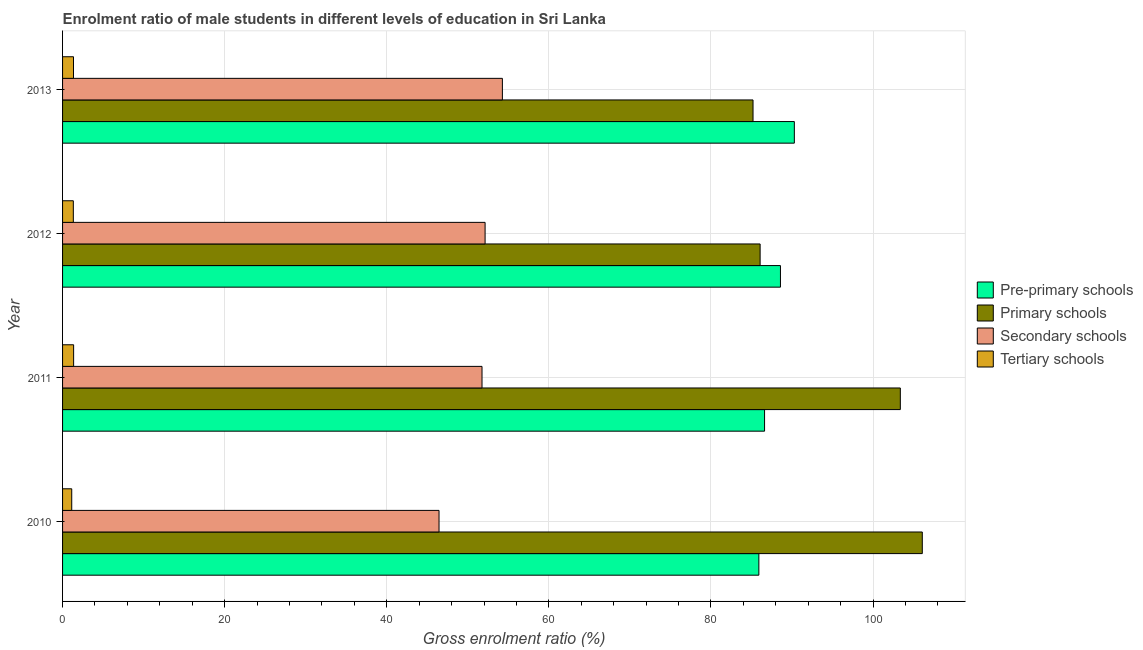How many different coloured bars are there?
Keep it short and to the point. 4. How many groups of bars are there?
Ensure brevity in your answer.  4. How many bars are there on the 4th tick from the bottom?
Keep it short and to the point. 4. In how many cases, is the number of bars for a given year not equal to the number of legend labels?
Offer a very short reply. 0. What is the gross enrolment ratio(female) in secondary schools in 2010?
Ensure brevity in your answer.  46.45. Across all years, what is the maximum gross enrolment ratio(female) in primary schools?
Give a very brief answer. 106.08. Across all years, what is the minimum gross enrolment ratio(female) in secondary schools?
Provide a short and direct response. 46.45. In which year was the gross enrolment ratio(female) in secondary schools minimum?
Provide a succinct answer. 2010. What is the total gross enrolment ratio(female) in tertiary schools in the graph?
Give a very brief answer. 5.17. What is the difference between the gross enrolment ratio(female) in tertiary schools in 2013 and the gross enrolment ratio(female) in pre-primary schools in 2011?
Provide a succinct answer. -85.27. What is the average gross enrolment ratio(female) in pre-primary schools per year?
Your response must be concise. 87.85. In the year 2010, what is the difference between the gross enrolment ratio(female) in secondary schools and gross enrolment ratio(female) in pre-primary schools?
Your answer should be very brief. -39.46. In how many years, is the gross enrolment ratio(female) in pre-primary schools greater than 20 %?
Your answer should be very brief. 4. What is the ratio of the gross enrolment ratio(female) in primary schools in 2012 to that in 2013?
Offer a terse response. 1.01. Is the difference between the gross enrolment ratio(female) in tertiary schools in 2010 and 2013 greater than the difference between the gross enrolment ratio(female) in secondary schools in 2010 and 2013?
Your response must be concise. Yes. What is the difference between the highest and the second highest gross enrolment ratio(female) in pre-primary schools?
Offer a very short reply. 1.71. What is the difference between the highest and the lowest gross enrolment ratio(female) in primary schools?
Your answer should be very brief. 20.89. What does the 3rd bar from the top in 2013 represents?
Provide a short and direct response. Primary schools. What does the 1st bar from the bottom in 2010 represents?
Offer a very short reply. Pre-primary schools. Are all the bars in the graph horizontal?
Keep it short and to the point. Yes. Does the graph contain any zero values?
Offer a terse response. No. Does the graph contain grids?
Provide a short and direct response. Yes. What is the title of the graph?
Your answer should be compact. Enrolment ratio of male students in different levels of education in Sri Lanka. What is the label or title of the X-axis?
Ensure brevity in your answer.  Gross enrolment ratio (%). What is the Gross enrolment ratio (%) in Pre-primary schools in 2010?
Your answer should be very brief. 85.91. What is the Gross enrolment ratio (%) in Primary schools in 2010?
Your answer should be compact. 106.08. What is the Gross enrolment ratio (%) of Secondary schools in 2010?
Keep it short and to the point. 46.45. What is the Gross enrolment ratio (%) of Tertiary schools in 2010?
Ensure brevity in your answer.  1.13. What is the Gross enrolment ratio (%) of Pre-primary schools in 2011?
Offer a very short reply. 86.62. What is the Gross enrolment ratio (%) of Primary schools in 2011?
Ensure brevity in your answer.  103.37. What is the Gross enrolment ratio (%) of Secondary schools in 2011?
Provide a succinct answer. 51.76. What is the Gross enrolment ratio (%) in Tertiary schools in 2011?
Make the answer very short. 1.36. What is the Gross enrolment ratio (%) in Pre-primary schools in 2012?
Offer a terse response. 88.58. What is the Gross enrolment ratio (%) of Primary schools in 2012?
Provide a succinct answer. 86.07. What is the Gross enrolment ratio (%) in Secondary schools in 2012?
Offer a terse response. 52.14. What is the Gross enrolment ratio (%) of Tertiary schools in 2012?
Provide a succinct answer. 1.33. What is the Gross enrolment ratio (%) of Pre-primary schools in 2013?
Provide a short and direct response. 90.29. What is the Gross enrolment ratio (%) in Primary schools in 2013?
Your answer should be compact. 85.19. What is the Gross enrolment ratio (%) of Secondary schools in 2013?
Offer a terse response. 54.27. What is the Gross enrolment ratio (%) of Tertiary schools in 2013?
Make the answer very short. 1.35. Across all years, what is the maximum Gross enrolment ratio (%) of Pre-primary schools?
Keep it short and to the point. 90.29. Across all years, what is the maximum Gross enrolment ratio (%) in Primary schools?
Offer a very short reply. 106.08. Across all years, what is the maximum Gross enrolment ratio (%) in Secondary schools?
Your response must be concise. 54.27. Across all years, what is the maximum Gross enrolment ratio (%) in Tertiary schools?
Make the answer very short. 1.36. Across all years, what is the minimum Gross enrolment ratio (%) in Pre-primary schools?
Ensure brevity in your answer.  85.91. Across all years, what is the minimum Gross enrolment ratio (%) in Primary schools?
Offer a terse response. 85.19. Across all years, what is the minimum Gross enrolment ratio (%) in Secondary schools?
Provide a succinct answer. 46.45. Across all years, what is the minimum Gross enrolment ratio (%) of Tertiary schools?
Give a very brief answer. 1.13. What is the total Gross enrolment ratio (%) in Pre-primary schools in the graph?
Keep it short and to the point. 351.4. What is the total Gross enrolment ratio (%) of Primary schools in the graph?
Your answer should be very brief. 380.72. What is the total Gross enrolment ratio (%) of Secondary schools in the graph?
Ensure brevity in your answer.  204.61. What is the total Gross enrolment ratio (%) in Tertiary schools in the graph?
Your response must be concise. 5.17. What is the difference between the Gross enrolment ratio (%) of Pre-primary schools in 2010 and that in 2011?
Keep it short and to the point. -0.7. What is the difference between the Gross enrolment ratio (%) of Primary schools in 2010 and that in 2011?
Ensure brevity in your answer.  2.71. What is the difference between the Gross enrolment ratio (%) in Secondary schools in 2010 and that in 2011?
Give a very brief answer. -5.3. What is the difference between the Gross enrolment ratio (%) in Tertiary schools in 2010 and that in 2011?
Offer a terse response. -0.23. What is the difference between the Gross enrolment ratio (%) of Pre-primary schools in 2010 and that in 2012?
Keep it short and to the point. -2.67. What is the difference between the Gross enrolment ratio (%) of Primary schools in 2010 and that in 2012?
Make the answer very short. 20.01. What is the difference between the Gross enrolment ratio (%) in Secondary schools in 2010 and that in 2012?
Make the answer very short. -5.68. What is the difference between the Gross enrolment ratio (%) of Tertiary schools in 2010 and that in 2012?
Your response must be concise. -0.2. What is the difference between the Gross enrolment ratio (%) in Pre-primary schools in 2010 and that in 2013?
Keep it short and to the point. -4.38. What is the difference between the Gross enrolment ratio (%) in Primary schools in 2010 and that in 2013?
Give a very brief answer. 20.89. What is the difference between the Gross enrolment ratio (%) in Secondary schools in 2010 and that in 2013?
Offer a terse response. -7.82. What is the difference between the Gross enrolment ratio (%) of Tertiary schools in 2010 and that in 2013?
Provide a succinct answer. -0.22. What is the difference between the Gross enrolment ratio (%) in Pre-primary schools in 2011 and that in 2012?
Provide a short and direct response. -1.96. What is the difference between the Gross enrolment ratio (%) in Primary schools in 2011 and that in 2012?
Ensure brevity in your answer.  17.3. What is the difference between the Gross enrolment ratio (%) of Secondary schools in 2011 and that in 2012?
Provide a short and direct response. -0.38. What is the difference between the Gross enrolment ratio (%) of Tertiary schools in 2011 and that in 2012?
Provide a succinct answer. 0.04. What is the difference between the Gross enrolment ratio (%) in Pre-primary schools in 2011 and that in 2013?
Offer a very short reply. -3.68. What is the difference between the Gross enrolment ratio (%) in Primary schools in 2011 and that in 2013?
Give a very brief answer. 18.18. What is the difference between the Gross enrolment ratio (%) in Secondary schools in 2011 and that in 2013?
Give a very brief answer. -2.51. What is the difference between the Gross enrolment ratio (%) of Tertiary schools in 2011 and that in 2013?
Ensure brevity in your answer.  0.02. What is the difference between the Gross enrolment ratio (%) in Pre-primary schools in 2012 and that in 2013?
Provide a succinct answer. -1.71. What is the difference between the Gross enrolment ratio (%) in Primary schools in 2012 and that in 2013?
Ensure brevity in your answer.  0.88. What is the difference between the Gross enrolment ratio (%) in Secondary schools in 2012 and that in 2013?
Keep it short and to the point. -2.13. What is the difference between the Gross enrolment ratio (%) in Tertiary schools in 2012 and that in 2013?
Your answer should be very brief. -0.02. What is the difference between the Gross enrolment ratio (%) in Pre-primary schools in 2010 and the Gross enrolment ratio (%) in Primary schools in 2011?
Your answer should be very brief. -17.46. What is the difference between the Gross enrolment ratio (%) of Pre-primary schools in 2010 and the Gross enrolment ratio (%) of Secondary schools in 2011?
Make the answer very short. 34.16. What is the difference between the Gross enrolment ratio (%) in Pre-primary schools in 2010 and the Gross enrolment ratio (%) in Tertiary schools in 2011?
Keep it short and to the point. 84.55. What is the difference between the Gross enrolment ratio (%) of Primary schools in 2010 and the Gross enrolment ratio (%) of Secondary schools in 2011?
Your answer should be compact. 54.33. What is the difference between the Gross enrolment ratio (%) of Primary schools in 2010 and the Gross enrolment ratio (%) of Tertiary schools in 2011?
Offer a terse response. 104.72. What is the difference between the Gross enrolment ratio (%) of Secondary schools in 2010 and the Gross enrolment ratio (%) of Tertiary schools in 2011?
Keep it short and to the point. 45.09. What is the difference between the Gross enrolment ratio (%) in Pre-primary schools in 2010 and the Gross enrolment ratio (%) in Primary schools in 2012?
Make the answer very short. -0.16. What is the difference between the Gross enrolment ratio (%) of Pre-primary schools in 2010 and the Gross enrolment ratio (%) of Secondary schools in 2012?
Your answer should be compact. 33.78. What is the difference between the Gross enrolment ratio (%) of Pre-primary schools in 2010 and the Gross enrolment ratio (%) of Tertiary schools in 2012?
Your response must be concise. 84.59. What is the difference between the Gross enrolment ratio (%) in Primary schools in 2010 and the Gross enrolment ratio (%) in Secondary schools in 2012?
Provide a short and direct response. 53.95. What is the difference between the Gross enrolment ratio (%) of Primary schools in 2010 and the Gross enrolment ratio (%) of Tertiary schools in 2012?
Offer a very short reply. 104.75. What is the difference between the Gross enrolment ratio (%) in Secondary schools in 2010 and the Gross enrolment ratio (%) in Tertiary schools in 2012?
Keep it short and to the point. 45.12. What is the difference between the Gross enrolment ratio (%) in Pre-primary schools in 2010 and the Gross enrolment ratio (%) in Primary schools in 2013?
Ensure brevity in your answer.  0.72. What is the difference between the Gross enrolment ratio (%) in Pre-primary schools in 2010 and the Gross enrolment ratio (%) in Secondary schools in 2013?
Provide a succinct answer. 31.64. What is the difference between the Gross enrolment ratio (%) in Pre-primary schools in 2010 and the Gross enrolment ratio (%) in Tertiary schools in 2013?
Your answer should be very brief. 84.57. What is the difference between the Gross enrolment ratio (%) of Primary schools in 2010 and the Gross enrolment ratio (%) of Secondary schools in 2013?
Your response must be concise. 51.81. What is the difference between the Gross enrolment ratio (%) of Primary schools in 2010 and the Gross enrolment ratio (%) of Tertiary schools in 2013?
Keep it short and to the point. 104.73. What is the difference between the Gross enrolment ratio (%) of Secondary schools in 2010 and the Gross enrolment ratio (%) of Tertiary schools in 2013?
Ensure brevity in your answer.  45.1. What is the difference between the Gross enrolment ratio (%) in Pre-primary schools in 2011 and the Gross enrolment ratio (%) in Primary schools in 2012?
Keep it short and to the point. 0.55. What is the difference between the Gross enrolment ratio (%) in Pre-primary schools in 2011 and the Gross enrolment ratio (%) in Secondary schools in 2012?
Provide a short and direct response. 34.48. What is the difference between the Gross enrolment ratio (%) of Pre-primary schools in 2011 and the Gross enrolment ratio (%) of Tertiary schools in 2012?
Keep it short and to the point. 85.29. What is the difference between the Gross enrolment ratio (%) in Primary schools in 2011 and the Gross enrolment ratio (%) in Secondary schools in 2012?
Your answer should be compact. 51.23. What is the difference between the Gross enrolment ratio (%) of Primary schools in 2011 and the Gross enrolment ratio (%) of Tertiary schools in 2012?
Keep it short and to the point. 102.04. What is the difference between the Gross enrolment ratio (%) in Secondary schools in 2011 and the Gross enrolment ratio (%) in Tertiary schools in 2012?
Offer a terse response. 50.43. What is the difference between the Gross enrolment ratio (%) in Pre-primary schools in 2011 and the Gross enrolment ratio (%) in Primary schools in 2013?
Provide a short and direct response. 1.42. What is the difference between the Gross enrolment ratio (%) in Pre-primary schools in 2011 and the Gross enrolment ratio (%) in Secondary schools in 2013?
Make the answer very short. 32.35. What is the difference between the Gross enrolment ratio (%) of Pre-primary schools in 2011 and the Gross enrolment ratio (%) of Tertiary schools in 2013?
Give a very brief answer. 85.27. What is the difference between the Gross enrolment ratio (%) in Primary schools in 2011 and the Gross enrolment ratio (%) in Secondary schools in 2013?
Keep it short and to the point. 49.1. What is the difference between the Gross enrolment ratio (%) in Primary schools in 2011 and the Gross enrolment ratio (%) in Tertiary schools in 2013?
Provide a short and direct response. 102.02. What is the difference between the Gross enrolment ratio (%) in Secondary schools in 2011 and the Gross enrolment ratio (%) in Tertiary schools in 2013?
Your answer should be compact. 50.41. What is the difference between the Gross enrolment ratio (%) in Pre-primary schools in 2012 and the Gross enrolment ratio (%) in Primary schools in 2013?
Provide a short and direct response. 3.38. What is the difference between the Gross enrolment ratio (%) in Pre-primary schools in 2012 and the Gross enrolment ratio (%) in Secondary schools in 2013?
Offer a very short reply. 34.31. What is the difference between the Gross enrolment ratio (%) in Pre-primary schools in 2012 and the Gross enrolment ratio (%) in Tertiary schools in 2013?
Keep it short and to the point. 87.23. What is the difference between the Gross enrolment ratio (%) of Primary schools in 2012 and the Gross enrolment ratio (%) of Secondary schools in 2013?
Offer a terse response. 31.8. What is the difference between the Gross enrolment ratio (%) in Primary schools in 2012 and the Gross enrolment ratio (%) in Tertiary schools in 2013?
Provide a succinct answer. 84.72. What is the difference between the Gross enrolment ratio (%) in Secondary schools in 2012 and the Gross enrolment ratio (%) in Tertiary schools in 2013?
Ensure brevity in your answer.  50.79. What is the average Gross enrolment ratio (%) in Pre-primary schools per year?
Keep it short and to the point. 87.85. What is the average Gross enrolment ratio (%) in Primary schools per year?
Your answer should be very brief. 95.18. What is the average Gross enrolment ratio (%) in Secondary schools per year?
Offer a very short reply. 51.15. What is the average Gross enrolment ratio (%) in Tertiary schools per year?
Provide a short and direct response. 1.29. In the year 2010, what is the difference between the Gross enrolment ratio (%) in Pre-primary schools and Gross enrolment ratio (%) in Primary schools?
Give a very brief answer. -20.17. In the year 2010, what is the difference between the Gross enrolment ratio (%) of Pre-primary schools and Gross enrolment ratio (%) of Secondary schools?
Provide a succinct answer. 39.46. In the year 2010, what is the difference between the Gross enrolment ratio (%) of Pre-primary schools and Gross enrolment ratio (%) of Tertiary schools?
Your answer should be very brief. 84.78. In the year 2010, what is the difference between the Gross enrolment ratio (%) in Primary schools and Gross enrolment ratio (%) in Secondary schools?
Offer a very short reply. 59.63. In the year 2010, what is the difference between the Gross enrolment ratio (%) in Primary schools and Gross enrolment ratio (%) in Tertiary schools?
Provide a succinct answer. 104.95. In the year 2010, what is the difference between the Gross enrolment ratio (%) in Secondary schools and Gross enrolment ratio (%) in Tertiary schools?
Give a very brief answer. 45.32. In the year 2011, what is the difference between the Gross enrolment ratio (%) of Pre-primary schools and Gross enrolment ratio (%) of Primary schools?
Keep it short and to the point. -16.75. In the year 2011, what is the difference between the Gross enrolment ratio (%) in Pre-primary schools and Gross enrolment ratio (%) in Secondary schools?
Your answer should be compact. 34.86. In the year 2011, what is the difference between the Gross enrolment ratio (%) of Pre-primary schools and Gross enrolment ratio (%) of Tertiary schools?
Your response must be concise. 85.25. In the year 2011, what is the difference between the Gross enrolment ratio (%) in Primary schools and Gross enrolment ratio (%) in Secondary schools?
Ensure brevity in your answer.  51.62. In the year 2011, what is the difference between the Gross enrolment ratio (%) of Primary schools and Gross enrolment ratio (%) of Tertiary schools?
Provide a succinct answer. 102.01. In the year 2011, what is the difference between the Gross enrolment ratio (%) of Secondary schools and Gross enrolment ratio (%) of Tertiary schools?
Make the answer very short. 50.39. In the year 2012, what is the difference between the Gross enrolment ratio (%) in Pre-primary schools and Gross enrolment ratio (%) in Primary schools?
Your answer should be compact. 2.51. In the year 2012, what is the difference between the Gross enrolment ratio (%) in Pre-primary schools and Gross enrolment ratio (%) in Secondary schools?
Offer a terse response. 36.44. In the year 2012, what is the difference between the Gross enrolment ratio (%) in Pre-primary schools and Gross enrolment ratio (%) in Tertiary schools?
Provide a short and direct response. 87.25. In the year 2012, what is the difference between the Gross enrolment ratio (%) of Primary schools and Gross enrolment ratio (%) of Secondary schools?
Make the answer very short. 33.93. In the year 2012, what is the difference between the Gross enrolment ratio (%) of Primary schools and Gross enrolment ratio (%) of Tertiary schools?
Make the answer very short. 84.74. In the year 2012, what is the difference between the Gross enrolment ratio (%) in Secondary schools and Gross enrolment ratio (%) in Tertiary schools?
Make the answer very short. 50.81. In the year 2013, what is the difference between the Gross enrolment ratio (%) of Pre-primary schools and Gross enrolment ratio (%) of Primary schools?
Give a very brief answer. 5.1. In the year 2013, what is the difference between the Gross enrolment ratio (%) in Pre-primary schools and Gross enrolment ratio (%) in Secondary schools?
Make the answer very short. 36.02. In the year 2013, what is the difference between the Gross enrolment ratio (%) in Pre-primary schools and Gross enrolment ratio (%) in Tertiary schools?
Provide a succinct answer. 88.94. In the year 2013, what is the difference between the Gross enrolment ratio (%) of Primary schools and Gross enrolment ratio (%) of Secondary schools?
Your answer should be compact. 30.93. In the year 2013, what is the difference between the Gross enrolment ratio (%) of Primary schools and Gross enrolment ratio (%) of Tertiary schools?
Offer a terse response. 83.85. In the year 2013, what is the difference between the Gross enrolment ratio (%) of Secondary schools and Gross enrolment ratio (%) of Tertiary schools?
Your answer should be very brief. 52.92. What is the ratio of the Gross enrolment ratio (%) in Primary schools in 2010 to that in 2011?
Offer a very short reply. 1.03. What is the ratio of the Gross enrolment ratio (%) of Secondary schools in 2010 to that in 2011?
Offer a terse response. 0.9. What is the ratio of the Gross enrolment ratio (%) of Tertiary schools in 2010 to that in 2011?
Give a very brief answer. 0.83. What is the ratio of the Gross enrolment ratio (%) in Pre-primary schools in 2010 to that in 2012?
Make the answer very short. 0.97. What is the ratio of the Gross enrolment ratio (%) of Primary schools in 2010 to that in 2012?
Ensure brevity in your answer.  1.23. What is the ratio of the Gross enrolment ratio (%) in Secondary schools in 2010 to that in 2012?
Your answer should be compact. 0.89. What is the ratio of the Gross enrolment ratio (%) of Tertiary schools in 2010 to that in 2012?
Your answer should be compact. 0.85. What is the ratio of the Gross enrolment ratio (%) of Pre-primary schools in 2010 to that in 2013?
Make the answer very short. 0.95. What is the ratio of the Gross enrolment ratio (%) in Primary schools in 2010 to that in 2013?
Provide a succinct answer. 1.25. What is the ratio of the Gross enrolment ratio (%) of Secondary schools in 2010 to that in 2013?
Offer a very short reply. 0.86. What is the ratio of the Gross enrolment ratio (%) of Tertiary schools in 2010 to that in 2013?
Provide a short and direct response. 0.84. What is the ratio of the Gross enrolment ratio (%) in Pre-primary schools in 2011 to that in 2012?
Provide a succinct answer. 0.98. What is the ratio of the Gross enrolment ratio (%) of Primary schools in 2011 to that in 2012?
Provide a succinct answer. 1.2. What is the ratio of the Gross enrolment ratio (%) in Secondary schools in 2011 to that in 2012?
Give a very brief answer. 0.99. What is the ratio of the Gross enrolment ratio (%) of Tertiary schools in 2011 to that in 2012?
Your answer should be compact. 1.03. What is the ratio of the Gross enrolment ratio (%) of Pre-primary schools in 2011 to that in 2013?
Your answer should be compact. 0.96. What is the ratio of the Gross enrolment ratio (%) in Primary schools in 2011 to that in 2013?
Provide a succinct answer. 1.21. What is the ratio of the Gross enrolment ratio (%) in Secondary schools in 2011 to that in 2013?
Keep it short and to the point. 0.95. What is the ratio of the Gross enrolment ratio (%) of Tertiary schools in 2011 to that in 2013?
Your answer should be very brief. 1.01. What is the ratio of the Gross enrolment ratio (%) in Primary schools in 2012 to that in 2013?
Your answer should be compact. 1.01. What is the ratio of the Gross enrolment ratio (%) of Secondary schools in 2012 to that in 2013?
Offer a very short reply. 0.96. What is the difference between the highest and the second highest Gross enrolment ratio (%) of Pre-primary schools?
Your answer should be compact. 1.71. What is the difference between the highest and the second highest Gross enrolment ratio (%) of Primary schools?
Provide a short and direct response. 2.71. What is the difference between the highest and the second highest Gross enrolment ratio (%) of Secondary schools?
Make the answer very short. 2.13. What is the difference between the highest and the second highest Gross enrolment ratio (%) in Tertiary schools?
Your answer should be compact. 0.02. What is the difference between the highest and the lowest Gross enrolment ratio (%) of Pre-primary schools?
Keep it short and to the point. 4.38. What is the difference between the highest and the lowest Gross enrolment ratio (%) in Primary schools?
Offer a very short reply. 20.89. What is the difference between the highest and the lowest Gross enrolment ratio (%) in Secondary schools?
Keep it short and to the point. 7.82. What is the difference between the highest and the lowest Gross enrolment ratio (%) of Tertiary schools?
Ensure brevity in your answer.  0.23. 